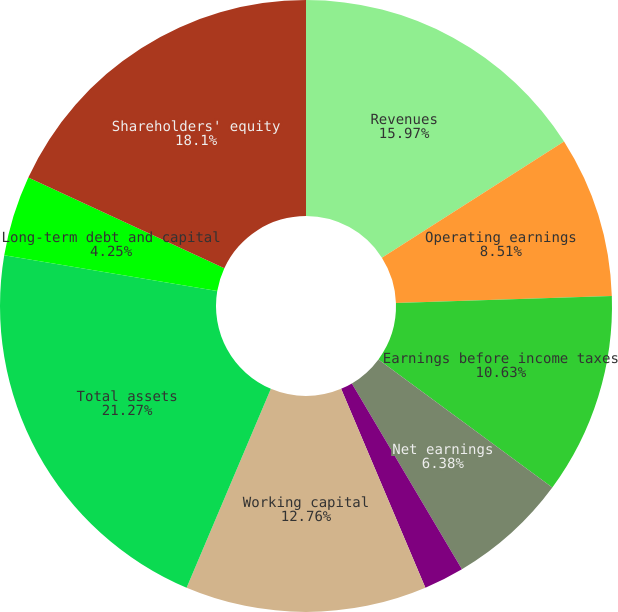Convert chart to OTSL. <chart><loc_0><loc_0><loc_500><loc_500><pie_chart><fcel>Revenues<fcel>Operating earnings<fcel>Earnings before income taxes<fcel>Net earnings<fcel>Basic<fcel>Diluted<fcel>Working capital<fcel>Total assets<fcel>Long-term debt and capital<fcel>Shareholders' equity<nl><fcel>15.97%<fcel>8.51%<fcel>10.63%<fcel>6.38%<fcel>2.13%<fcel>0.0%<fcel>12.76%<fcel>21.27%<fcel>4.25%<fcel>18.1%<nl></chart> 